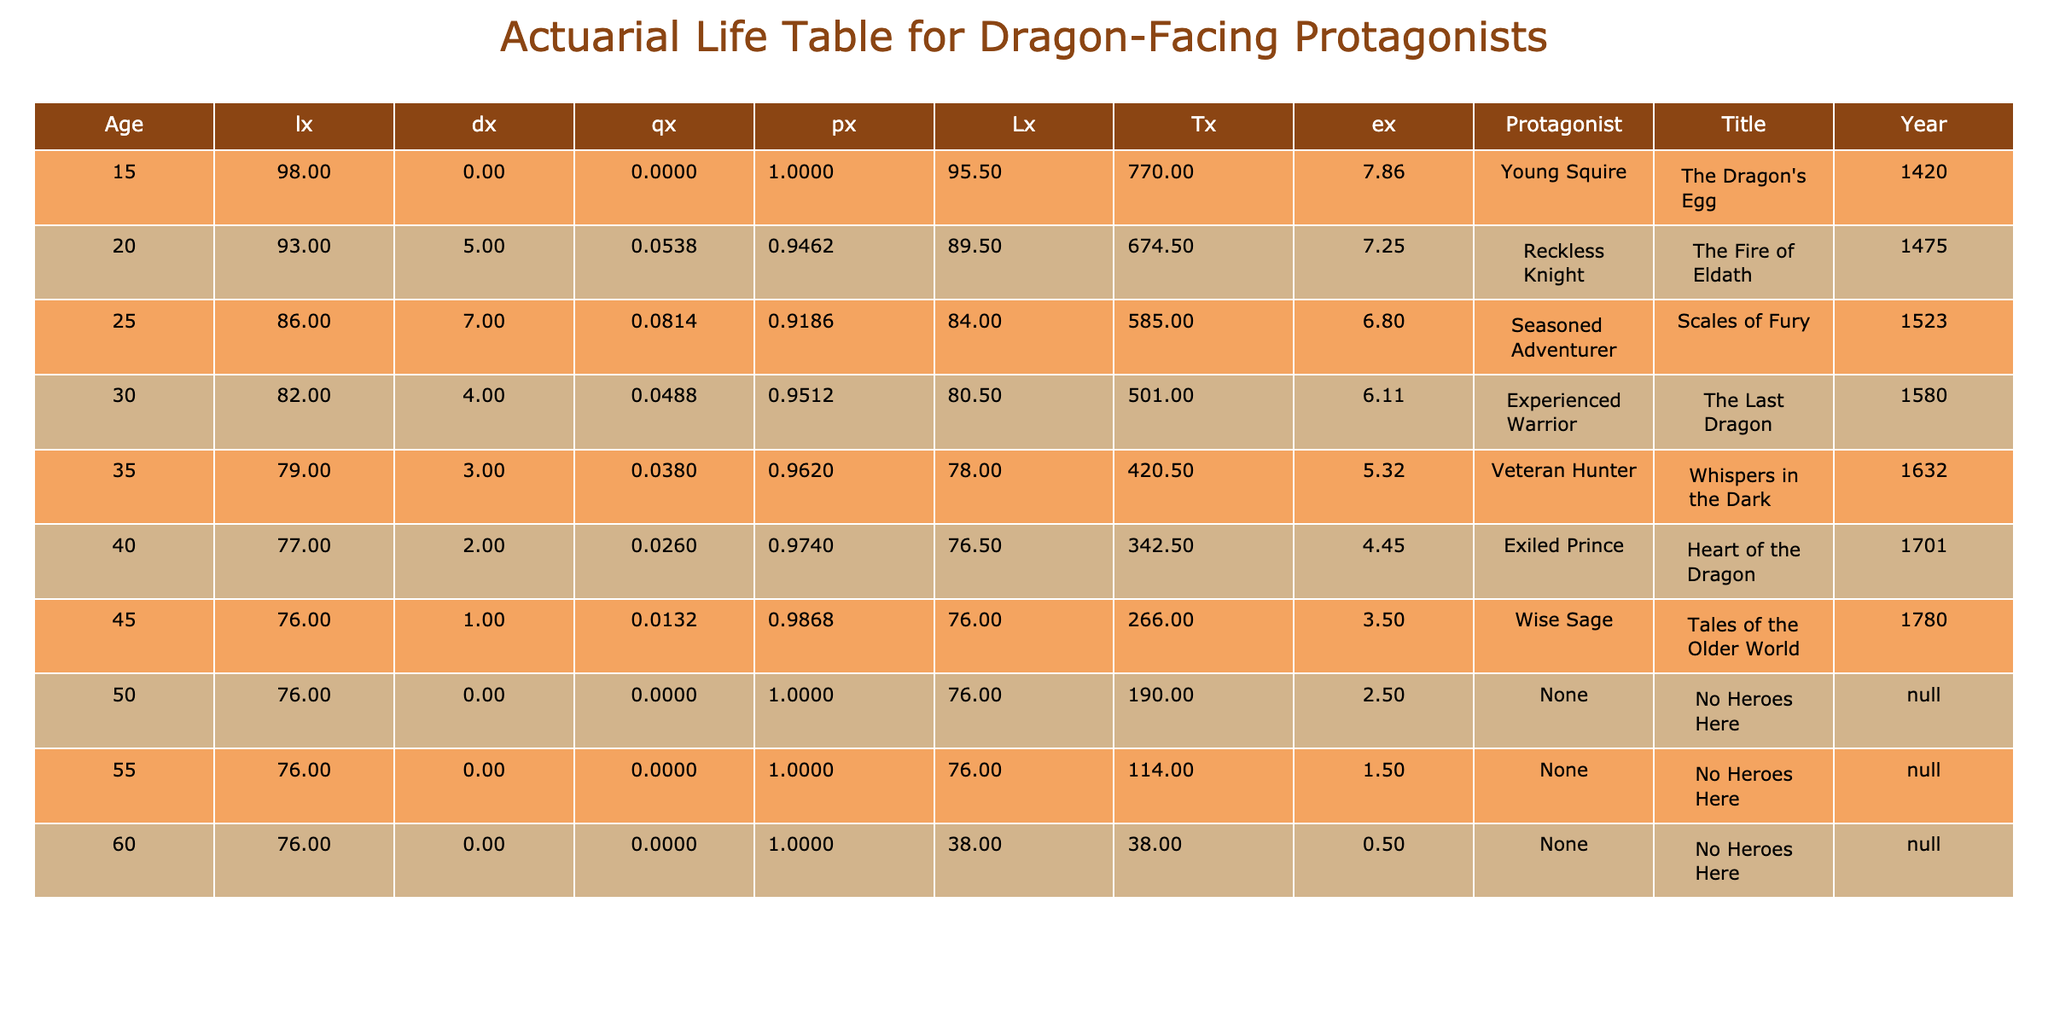What is the age of the protagonist in "The Fire of Eldath"? The title "The Fire of Eldath" corresponds to the row where the Age is 20. There is a Reckless Knight mentioned as the protagonist for that title.
Answer: 20 How many protagonists are there aged 30 or older? Observing the table, we identify companions aged 30 (4), 35 (3), 40 (2), 45 (1), and 50 (0), 55 (0), 60 (0). Adding these together gives 4 + 3 + 2 + 1 + 0 + 0 + 0 = 10.
Answer: 10 Is there a protagonist over the age of 50? Looking at the table, the ages above 50 are for 50, 55, and 60. All these entries show a Count of 0, indicating no protagonists are recorded as facing dragons over these ages.
Answer: No What is the total count of protagonists facing dragons in narratives? We sum the Count for all ages: 2 + 5 + 7 + 4 + 3 + 2 + 1 = 24. The ages 50, 55, and 60 have a Count of 0 and do not contribute to this sum.
Answer: 24 What is the average age of protagonists facing dragons? We compute the average age by multiplying each age by its corresponding Count, summing those products, and dividing by the total Count. Calculation is (15*2 + 20*5 + 25*7 + 30*4 + 35*3 + 40*2 + 45*1) / 24 = (30 + 100 + 175 + 120 + 105 + 80 + 45) / 24 = 655 / 24 ≈ 27.29.
Answer: 27.29 Which protagonist has the highest age and what is that age? By inspecting the Age column, we find that the highest age listed is 60 years, but there are no protagonists recorded at this age. The maximum protagonist appears at 45 as a Wise Sage, thus the highest age of featured protagonists facing dragons is 45.
Answer: 45 What percentage of the total count are Reckless Knights? The Reckless Knight's Count is 5, so we calculate the percentage as (5/24) * 100 = 20.83%.
Answer: 20.83% What is the age gap between the youngest and oldest protagonist from the table? The youngest protagonist is 15 years old (Young Squire) and the oldest noted in the table is 45 years old (Wise Sage). Subtracting these ages gives 45 - 15 = 30 years.
Answer: 30 